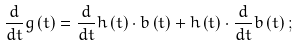<formula> <loc_0><loc_0><loc_500><loc_500>\frac { d } { d t } g \left ( t \right ) = \frac { d } { d t } h \left ( t \right ) \cdot b \left ( t \right ) + h \left ( t \right ) \cdot \frac { d } { d t } b \left ( t \right ) ;</formula> 